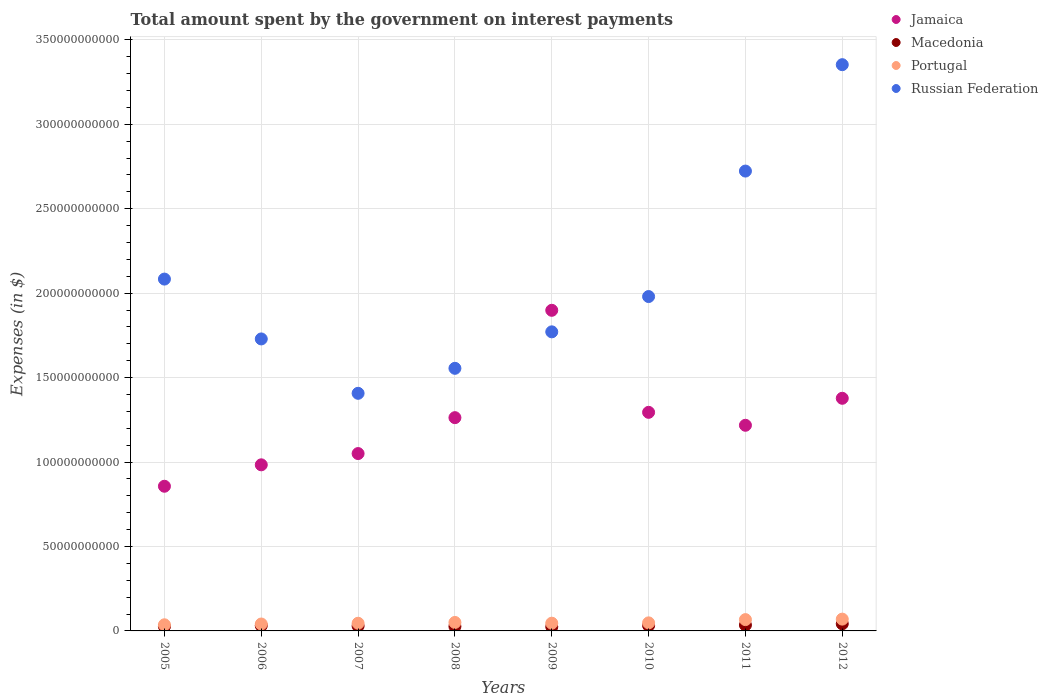How many different coloured dotlines are there?
Ensure brevity in your answer.  4. What is the amount spent on interest payments by the government in Portugal in 2006?
Offer a very short reply. 4.10e+09. Across all years, what is the maximum amount spent on interest payments by the government in Jamaica?
Keep it short and to the point. 1.90e+11. Across all years, what is the minimum amount spent on interest payments by the government in Russian Federation?
Offer a very short reply. 1.41e+11. In which year was the amount spent on interest payments by the government in Jamaica minimum?
Your response must be concise. 2005. What is the total amount spent on interest payments by the government in Russian Federation in the graph?
Your answer should be compact. 1.66e+12. What is the difference between the amount spent on interest payments by the government in Portugal in 2005 and that in 2010?
Your answer should be compact. -1.14e+09. What is the difference between the amount spent on interest payments by the government in Portugal in 2010 and the amount spent on interest payments by the government in Macedonia in 2007?
Offer a terse response. 1.85e+09. What is the average amount spent on interest payments by the government in Russian Federation per year?
Give a very brief answer. 2.08e+11. In the year 2011, what is the difference between the amount spent on interest payments by the government in Jamaica and amount spent on interest payments by the government in Macedonia?
Ensure brevity in your answer.  1.18e+11. What is the ratio of the amount spent on interest payments by the government in Portugal in 2005 to that in 2007?
Give a very brief answer. 0.8. Is the amount spent on interest payments by the government in Portugal in 2008 less than that in 2010?
Keep it short and to the point. No. What is the difference between the highest and the second highest amount spent on interest payments by the government in Jamaica?
Provide a succinct answer. 5.21e+1. What is the difference between the highest and the lowest amount spent on interest payments by the government in Jamaica?
Your answer should be compact. 1.04e+11. In how many years, is the amount spent on interest payments by the government in Portugal greater than the average amount spent on interest payments by the government in Portugal taken over all years?
Provide a short and direct response. 2. Is the sum of the amount spent on interest payments by the government in Jamaica in 2008 and 2012 greater than the maximum amount spent on interest payments by the government in Macedonia across all years?
Provide a short and direct response. Yes. Is it the case that in every year, the sum of the amount spent on interest payments by the government in Jamaica and amount spent on interest payments by the government in Portugal  is greater than the sum of amount spent on interest payments by the government in Russian Federation and amount spent on interest payments by the government in Macedonia?
Your answer should be very brief. Yes. Does the amount spent on interest payments by the government in Macedonia monotonically increase over the years?
Your response must be concise. No. Is the amount spent on interest payments by the government in Macedonia strictly greater than the amount spent on interest payments by the government in Portugal over the years?
Give a very brief answer. No. Is the amount spent on interest payments by the government in Portugal strictly less than the amount spent on interest payments by the government in Russian Federation over the years?
Ensure brevity in your answer.  Yes. How many dotlines are there?
Make the answer very short. 4. What is the difference between two consecutive major ticks on the Y-axis?
Provide a succinct answer. 5.00e+1. Are the values on the major ticks of Y-axis written in scientific E-notation?
Provide a succinct answer. No. What is the title of the graph?
Make the answer very short. Total amount spent by the government on interest payments. What is the label or title of the X-axis?
Your answer should be very brief. Years. What is the label or title of the Y-axis?
Give a very brief answer. Expenses (in $). What is the Expenses (in $) of Jamaica in 2005?
Offer a very short reply. 8.57e+1. What is the Expenses (in $) in Macedonia in 2005?
Keep it short and to the point. 2.62e+09. What is the Expenses (in $) of Portugal in 2005?
Your answer should be compact. 3.63e+09. What is the Expenses (in $) of Russian Federation in 2005?
Give a very brief answer. 2.08e+11. What is the Expenses (in $) in Jamaica in 2006?
Provide a short and direct response. 9.84e+1. What is the Expenses (in $) of Macedonia in 2006?
Keep it short and to the point. 3.14e+09. What is the Expenses (in $) of Portugal in 2006?
Give a very brief answer. 4.10e+09. What is the Expenses (in $) in Russian Federation in 2006?
Your answer should be very brief. 1.73e+11. What is the Expenses (in $) of Jamaica in 2007?
Keep it short and to the point. 1.05e+11. What is the Expenses (in $) in Macedonia in 2007?
Provide a succinct answer. 2.92e+09. What is the Expenses (in $) of Portugal in 2007?
Ensure brevity in your answer.  4.54e+09. What is the Expenses (in $) in Russian Federation in 2007?
Ensure brevity in your answer.  1.41e+11. What is the Expenses (in $) in Jamaica in 2008?
Ensure brevity in your answer.  1.26e+11. What is the Expenses (in $) of Macedonia in 2008?
Provide a succinct answer. 2.65e+09. What is the Expenses (in $) in Portugal in 2008?
Provide a short and direct response. 5.02e+09. What is the Expenses (in $) in Russian Federation in 2008?
Give a very brief answer. 1.56e+11. What is the Expenses (in $) of Jamaica in 2009?
Provide a short and direct response. 1.90e+11. What is the Expenses (in $) in Macedonia in 2009?
Ensure brevity in your answer.  2.44e+09. What is the Expenses (in $) in Portugal in 2009?
Offer a very short reply. 4.58e+09. What is the Expenses (in $) in Russian Federation in 2009?
Give a very brief answer. 1.77e+11. What is the Expenses (in $) of Jamaica in 2010?
Your response must be concise. 1.29e+11. What is the Expenses (in $) of Macedonia in 2010?
Your answer should be very brief. 3.17e+09. What is the Expenses (in $) of Portugal in 2010?
Offer a terse response. 4.77e+09. What is the Expenses (in $) in Russian Federation in 2010?
Provide a succinct answer. 1.98e+11. What is the Expenses (in $) in Jamaica in 2011?
Provide a short and direct response. 1.22e+11. What is the Expenses (in $) of Macedonia in 2011?
Your answer should be very brief. 3.47e+09. What is the Expenses (in $) in Portugal in 2011?
Ensure brevity in your answer.  6.69e+09. What is the Expenses (in $) in Russian Federation in 2011?
Your response must be concise. 2.72e+11. What is the Expenses (in $) of Jamaica in 2012?
Your response must be concise. 1.38e+11. What is the Expenses (in $) of Macedonia in 2012?
Your response must be concise. 4.22e+09. What is the Expenses (in $) in Portugal in 2012?
Your answer should be compact. 6.98e+09. What is the Expenses (in $) in Russian Federation in 2012?
Your answer should be very brief. 3.35e+11. Across all years, what is the maximum Expenses (in $) in Jamaica?
Offer a terse response. 1.90e+11. Across all years, what is the maximum Expenses (in $) of Macedonia?
Make the answer very short. 4.22e+09. Across all years, what is the maximum Expenses (in $) of Portugal?
Offer a very short reply. 6.98e+09. Across all years, what is the maximum Expenses (in $) of Russian Federation?
Ensure brevity in your answer.  3.35e+11. Across all years, what is the minimum Expenses (in $) of Jamaica?
Ensure brevity in your answer.  8.57e+1. Across all years, what is the minimum Expenses (in $) of Macedonia?
Provide a succinct answer. 2.44e+09. Across all years, what is the minimum Expenses (in $) in Portugal?
Your answer should be very brief. 3.63e+09. Across all years, what is the minimum Expenses (in $) of Russian Federation?
Give a very brief answer. 1.41e+11. What is the total Expenses (in $) of Jamaica in the graph?
Ensure brevity in your answer.  9.94e+11. What is the total Expenses (in $) of Macedonia in the graph?
Provide a succinct answer. 2.46e+1. What is the total Expenses (in $) in Portugal in the graph?
Your answer should be very brief. 4.03e+1. What is the total Expenses (in $) of Russian Federation in the graph?
Offer a terse response. 1.66e+12. What is the difference between the Expenses (in $) in Jamaica in 2005 and that in 2006?
Your response must be concise. -1.27e+1. What is the difference between the Expenses (in $) in Macedonia in 2005 and that in 2006?
Offer a very short reply. -5.20e+08. What is the difference between the Expenses (in $) of Portugal in 2005 and that in 2006?
Your answer should be compact. -4.63e+08. What is the difference between the Expenses (in $) of Russian Federation in 2005 and that in 2006?
Ensure brevity in your answer.  3.54e+1. What is the difference between the Expenses (in $) of Jamaica in 2005 and that in 2007?
Your response must be concise. -1.94e+1. What is the difference between the Expenses (in $) of Macedonia in 2005 and that in 2007?
Provide a succinct answer. -2.99e+08. What is the difference between the Expenses (in $) of Portugal in 2005 and that in 2007?
Your answer should be compact. -9.07e+08. What is the difference between the Expenses (in $) of Russian Federation in 2005 and that in 2007?
Offer a terse response. 6.76e+1. What is the difference between the Expenses (in $) of Jamaica in 2005 and that in 2008?
Your response must be concise. -4.06e+1. What is the difference between the Expenses (in $) in Macedonia in 2005 and that in 2008?
Ensure brevity in your answer.  -2.62e+07. What is the difference between the Expenses (in $) of Portugal in 2005 and that in 2008?
Give a very brief answer. -1.39e+09. What is the difference between the Expenses (in $) of Russian Federation in 2005 and that in 2008?
Make the answer very short. 5.28e+1. What is the difference between the Expenses (in $) in Jamaica in 2005 and that in 2009?
Make the answer very short. -1.04e+11. What is the difference between the Expenses (in $) in Macedonia in 2005 and that in 2009?
Your response must be concise. 1.75e+08. What is the difference between the Expenses (in $) of Portugal in 2005 and that in 2009?
Provide a short and direct response. -9.44e+08. What is the difference between the Expenses (in $) of Russian Federation in 2005 and that in 2009?
Provide a short and direct response. 3.12e+1. What is the difference between the Expenses (in $) of Jamaica in 2005 and that in 2010?
Your answer should be compact. -4.38e+1. What is the difference between the Expenses (in $) in Macedonia in 2005 and that in 2010?
Provide a succinct answer. -5.54e+08. What is the difference between the Expenses (in $) of Portugal in 2005 and that in 2010?
Make the answer very short. -1.14e+09. What is the difference between the Expenses (in $) of Russian Federation in 2005 and that in 2010?
Make the answer very short. 1.03e+1. What is the difference between the Expenses (in $) in Jamaica in 2005 and that in 2011?
Provide a succinct answer. -3.61e+1. What is the difference between the Expenses (in $) in Macedonia in 2005 and that in 2011?
Your response must be concise. -8.51e+08. What is the difference between the Expenses (in $) of Portugal in 2005 and that in 2011?
Make the answer very short. -3.06e+09. What is the difference between the Expenses (in $) in Russian Federation in 2005 and that in 2011?
Give a very brief answer. -6.40e+1. What is the difference between the Expenses (in $) of Jamaica in 2005 and that in 2012?
Make the answer very short. -5.21e+1. What is the difference between the Expenses (in $) in Macedonia in 2005 and that in 2012?
Offer a very short reply. -1.60e+09. What is the difference between the Expenses (in $) of Portugal in 2005 and that in 2012?
Your answer should be very brief. -3.35e+09. What is the difference between the Expenses (in $) in Russian Federation in 2005 and that in 2012?
Ensure brevity in your answer.  -1.27e+11. What is the difference between the Expenses (in $) in Jamaica in 2006 and that in 2007?
Your answer should be compact. -6.67e+09. What is the difference between the Expenses (in $) of Macedonia in 2006 and that in 2007?
Your answer should be very brief. 2.22e+08. What is the difference between the Expenses (in $) of Portugal in 2006 and that in 2007?
Offer a very short reply. -4.44e+08. What is the difference between the Expenses (in $) in Russian Federation in 2006 and that in 2007?
Your response must be concise. 3.22e+1. What is the difference between the Expenses (in $) of Jamaica in 2006 and that in 2008?
Your answer should be compact. -2.79e+1. What is the difference between the Expenses (in $) in Macedonia in 2006 and that in 2008?
Ensure brevity in your answer.  4.94e+08. What is the difference between the Expenses (in $) of Portugal in 2006 and that in 2008?
Offer a very short reply. -9.23e+08. What is the difference between the Expenses (in $) of Russian Federation in 2006 and that in 2008?
Give a very brief answer. 1.74e+1. What is the difference between the Expenses (in $) in Jamaica in 2006 and that in 2009?
Your answer should be compact. -9.15e+1. What is the difference between the Expenses (in $) in Macedonia in 2006 and that in 2009?
Provide a succinct answer. 6.95e+08. What is the difference between the Expenses (in $) of Portugal in 2006 and that in 2009?
Keep it short and to the point. -4.81e+08. What is the difference between the Expenses (in $) in Russian Federation in 2006 and that in 2009?
Offer a very short reply. -4.20e+09. What is the difference between the Expenses (in $) of Jamaica in 2006 and that in 2010?
Give a very brief answer. -3.11e+1. What is the difference between the Expenses (in $) of Macedonia in 2006 and that in 2010?
Keep it short and to the point. -3.39e+07. What is the difference between the Expenses (in $) in Portugal in 2006 and that in 2010?
Provide a succinct answer. -6.76e+08. What is the difference between the Expenses (in $) of Russian Federation in 2006 and that in 2010?
Make the answer very short. -2.51e+1. What is the difference between the Expenses (in $) in Jamaica in 2006 and that in 2011?
Provide a short and direct response. -2.34e+1. What is the difference between the Expenses (in $) in Macedonia in 2006 and that in 2011?
Give a very brief answer. -3.31e+08. What is the difference between the Expenses (in $) in Portugal in 2006 and that in 2011?
Ensure brevity in your answer.  -2.60e+09. What is the difference between the Expenses (in $) in Russian Federation in 2006 and that in 2011?
Your answer should be very brief. -9.94e+1. What is the difference between the Expenses (in $) of Jamaica in 2006 and that in 2012?
Ensure brevity in your answer.  -3.94e+1. What is the difference between the Expenses (in $) of Macedonia in 2006 and that in 2012?
Provide a short and direct response. -1.08e+09. What is the difference between the Expenses (in $) in Portugal in 2006 and that in 2012?
Offer a terse response. -2.89e+09. What is the difference between the Expenses (in $) of Russian Federation in 2006 and that in 2012?
Make the answer very short. -1.62e+11. What is the difference between the Expenses (in $) in Jamaica in 2007 and that in 2008?
Offer a terse response. -2.13e+1. What is the difference between the Expenses (in $) of Macedonia in 2007 and that in 2008?
Offer a terse response. 2.72e+08. What is the difference between the Expenses (in $) of Portugal in 2007 and that in 2008?
Make the answer very short. -4.79e+08. What is the difference between the Expenses (in $) of Russian Federation in 2007 and that in 2008?
Offer a very short reply. -1.48e+1. What is the difference between the Expenses (in $) of Jamaica in 2007 and that in 2009?
Offer a very short reply. -8.48e+1. What is the difference between the Expenses (in $) of Macedonia in 2007 and that in 2009?
Provide a short and direct response. 4.73e+08. What is the difference between the Expenses (in $) of Portugal in 2007 and that in 2009?
Provide a short and direct response. -3.71e+07. What is the difference between the Expenses (in $) of Russian Federation in 2007 and that in 2009?
Give a very brief answer. -3.64e+1. What is the difference between the Expenses (in $) in Jamaica in 2007 and that in 2010?
Offer a very short reply. -2.44e+1. What is the difference between the Expenses (in $) in Macedonia in 2007 and that in 2010?
Offer a terse response. -2.56e+08. What is the difference between the Expenses (in $) of Portugal in 2007 and that in 2010?
Give a very brief answer. -2.32e+08. What is the difference between the Expenses (in $) of Russian Federation in 2007 and that in 2010?
Make the answer very short. -5.73e+1. What is the difference between the Expenses (in $) of Jamaica in 2007 and that in 2011?
Ensure brevity in your answer.  -1.67e+1. What is the difference between the Expenses (in $) of Macedonia in 2007 and that in 2011?
Keep it short and to the point. -5.53e+08. What is the difference between the Expenses (in $) of Portugal in 2007 and that in 2011?
Keep it short and to the point. -2.15e+09. What is the difference between the Expenses (in $) of Russian Federation in 2007 and that in 2011?
Offer a terse response. -1.32e+11. What is the difference between the Expenses (in $) of Jamaica in 2007 and that in 2012?
Provide a succinct answer. -3.27e+1. What is the difference between the Expenses (in $) of Macedonia in 2007 and that in 2012?
Your answer should be compact. -1.30e+09. What is the difference between the Expenses (in $) in Portugal in 2007 and that in 2012?
Provide a succinct answer. -2.44e+09. What is the difference between the Expenses (in $) of Russian Federation in 2007 and that in 2012?
Your answer should be very brief. -1.95e+11. What is the difference between the Expenses (in $) of Jamaica in 2008 and that in 2009?
Ensure brevity in your answer.  -6.36e+1. What is the difference between the Expenses (in $) in Macedonia in 2008 and that in 2009?
Offer a very short reply. 2.01e+08. What is the difference between the Expenses (in $) in Portugal in 2008 and that in 2009?
Make the answer very short. 4.42e+08. What is the difference between the Expenses (in $) in Russian Federation in 2008 and that in 2009?
Provide a short and direct response. -2.16e+1. What is the difference between the Expenses (in $) of Jamaica in 2008 and that in 2010?
Your response must be concise. -3.15e+09. What is the difference between the Expenses (in $) in Macedonia in 2008 and that in 2010?
Offer a very short reply. -5.28e+08. What is the difference between the Expenses (in $) in Portugal in 2008 and that in 2010?
Your answer should be compact. 2.47e+08. What is the difference between the Expenses (in $) in Russian Federation in 2008 and that in 2010?
Offer a terse response. -4.25e+1. What is the difference between the Expenses (in $) in Jamaica in 2008 and that in 2011?
Provide a short and direct response. 4.51e+09. What is the difference between the Expenses (in $) in Macedonia in 2008 and that in 2011?
Give a very brief answer. -8.25e+08. What is the difference between the Expenses (in $) in Portugal in 2008 and that in 2011?
Provide a short and direct response. -1.68e+09. What is the difference between the Expenses (in $) in Russian Federation in 2008 and that in 2011?
Provide a short and direct response. -1.17e+11. What is the difference between the Expenses (in $) of Jamaica in 2008 and that in 2012?
Your response must be concise. -1.15e+1. What is the difference between the Expenses (in $) in Macedonia in 2008 and that in 2012?
Ensure brevity in your answer.  -1.57e+09. What is the difference between the Expenses (in $) in Portugal in 2008 and that in 2012?
Keep it short and to the point. -1.96e+09. What is the difference between the Expenses (in $) in Russian Federation in 2008 and that in 2012?
Keep it short and to the point. -1.80e+11. What is the difference between the Expenses (in $) in Jamaica in 2009 and that in 2010?
Offer a terse response. 6.04e+1. What is the difference between the Expenses (in $) in Macedonia in 2009 and that in 2010?
Offer a terse response. -7.29e+08. What is the difference between the Expenses (in $) of Portugal in 2009 and that in 2010?
Offer a very short reply. -1.95e+08. What is the difference between the Expenses (in $) in Russian Federation in 2009 and that in 2010?
Provide a short and direct response. -2.09e+1. What is the difference between the Expenses (in $) in Jamaica in 2009 and that in 2011?
Make the answer very short. 6.81e+1. What is the difference between the Expenses (in $) in Macedonia in 2009 and that in 2011?
Offer a very short reply. -1.03e+09. What is the difference between the Expenses (in $) in Portugal in 2009 and that in 2011?
Your answer should be very brief. -2.12e+09. What is the difference between the Expenses (in $) in Russian Federation in 2009 and that in 2011?
Your answer should be compact. -9.52e+1. What is the difference between the Expenses (in $) in Jamaica in 2009 and that in 2012?
Offer a very short reply. 5.21e+1. What is the difference between the Expenses (in $) of Macedonia in 2009 and that in 2012?
Give a very brief answer. -1.77e+09. What is the difference between the Expenses (in $) in Portugal in 2009 and that in 2012?
Your response must be concise. -2.41e+09. What is the difference between the Expenses (in $) in Russian Federation in 2009 and that in 2012?
Your answer should be very brief. -1.58e+11. What is the difference between the Expenses (in $) of Jamaica in 2010 and that in 2011?
Provide a short and direct response. 7.67e+09. What is the difference between the Expenses (in $) in Macedonia in 2010 and that in 2011?
Provide a short and direct response. -2.97e+08. What is the difference between the Expenses (in $) of Portugal in 2010 and that in 2011?
Your response must be concise. -1.92e+09. What is the difference between the Expenses (in $) of Russian Federation in 2010 and that in 2011?
Offer a very short reply. -7.43e+1. What is the difference between the Expenses (in $) in Jamaica in 2010 and that in 2012?
Offer a terse response. -8.32e+09. What is the difference between the Expenses (in $) in Macedonia in 2010 and that in 2012?
Make the answer very short. -1.04e+09. What is the difference between the Expenses (in $) in Portugal in 2010 and that in 2012?
Provide a short and direct response. -2.21e+09. What is the difference between the Expenses (in $) of Russian Federation in 2010 and that in 2012?
Give a very brief answer. -1.37e+11. What is the difference between the Expenses (in $) in Jamaica in 2011 and that in 2012?
Provide a short and direct response. -1.60e+1. What is the difference between the Expenses (in $) of Macedonia in 2011 and that in 2012?
Give a very brief answer. -7.45e+08. What is the difference between the Expenses (in $) of Portugal in 2011 and that in 2012?
Provide a short and direct response. -2.90e+08. What is the difference between the Expenses (in $) of Russian Federation in 2011 and that in 2012?
Give a very brief answer. -6.30e+1. What is the difference between the Expenses (in $) in Jamaica in 2005 and the Expenses (in $) in Macedonia in 2006?
Keep it short and to the point. 8.25e+1. What is the difference between the Expenses (in $) in Jamaica in 2005 and the Expenses (in $) in Portugal in 2006?
Offer a very short reply. 8.16e+1. What is the difference between the Expenses (in $) of Jamaica in 2005 and the Expenses (in $) of Russian Federation in 2006?
Your response must be concise. -8.72e+1. What is the difference between the Expenses (in $) in Macedonia in 2005 and the Expenses (in $) in Portugal in 2006?
Your response must be concise. -1.48e+09. What is the difference between the Expenses (in $) of Macedonia in 2005 and the Expenses (in $) of Russian Federation in 2006?
Your answer should be very brief. -1.70e+11. What is the difference between the Expenses (in $) in Portugal in 2005 and the Expenses (in $) in Russian Federation in 2006?
Provide a succinct answer. -1.69e+11. What is the difference between the Expenses (in $) of Jamaica in 2005 and the Expenses (in $) of Macedonia in 2007?
Your response must be concise. 8.27e+1. What is the difference between the Expenses (in $) in Jamaica in 2005 and the Expenses (in $) in Portugal in 2007?
Provide a short and direct response. 8.11e+1. What is the difference between the Expenses (in $) in Jamaica in 2005 and the Expenses (in $) in Russian Federation in 2007?
Your response must be concise. -5.50e+1. What is the difference between the Expenses (in $) in Macedonia in 2005 and the Expenses (in $) in Portugal in 2007?
Your response must be concise. -1.92e+09. What is the difference between the Expenses (in $) in Macedonia in 2005 and the Expenses (in $) in Russian Federation in 2007?
Your response must be concise. -1.38e+11. What is the difference between the Expenses (in $) in Portugal in 2005 and the Expenses (in $) in Russian Federation in 2007?
Provide a succinct answer. -1.37e+11. What is the difference between the Expenses (in $) in Jamaica in 2005 and the Expenses (in $) in Macedonia in 2008?
Offer a very short reply. 8.30e+1. What is the difference between the Expenses (in $) of Jamaica in 2005 and the Expenses (in $) of Portugal in 2008?
Provide a succinct answer. 8.06e+1. What is the difference between the Expenses (in $) of Jamaica in 2005 and the Expenses (in $) of Russian Federation in 2008?
Your response must be concise. -6.98e+1. What is the difference between the Expenses (in $) in Macedonia in 2005 and the Expenses (in $) in Portugal in 2008?
Your response must be concise. -2.40e+09. What is the difference between the Expenses (in $) of Macedonia in 2005 and the Expenses (in $) of Russian Federation in 2008?
Keep it short and to the point. -1.53e+11. What is the difference between the Expenses (in $) of Portugal in 2005 and the Expenses (in $) of Russian Federation in 2008?
Make the answer very short. -1.52e+11. What is the difference between the Expenses (in $) in Jamaica in 2005 and the Expenses (in $) in Macedonia in 2009?
Provide a succinct answer. 8.32e+1. What is the difference between the Expenses (in $) in Jamaica in 2005 and the Expenses (in $) in Portugal in 2009?
Keep it short and to the point. 8.11e+1. What is the difference between the Expenses (in $) in Jamaica in 2005 and the Expenses (in $) in Russian Federation in 2009?
Make the answer very short. -9.14e+1. What is the difference between the Expenses (in $) of Macedonia in 2005 and the Expenses (in $) of Portugal in 2009?
Ensure brevity in your answer.  -1.96e+09. What is the difference between the Expenses (in $) in Macedonia in 2005 and the Expenses (in $) in Russian Federation in 2009?
Your answer should be compact. -1.74e+11. What is the difference between the Expenses (in $) of Portugal in 2005 and the Expenses (in $) of Russian Federation in 2009?
Your answer should be compact. -1.73e+11. What is the difference between the Expenses (in $) in Jamaica in 2005 and the Expenses (in $) in Macedonia in 2010?
Keep it short and to the point. 8.25e+1. What is the difference between the Expenses (in $) in Jamaica in 2005 and the Expenses (in $) in Portugal in 2010?
Your answer should be compact. 8.09e+1. What is the difference between the Expenses (in $) of Jamaica in 2005 and the Expenses (in $) of Russian Federation in 2010?
Offer a terse response. -1.12e+11. What is the difference between the Expenses (in $) in Macedonia in 2005 and the Expenses (in $) in Portugal in 2010?
Offer a very short reply. -2.15e+09. What is the difference between the Expenses (in $) of Macedonia in 2005 and the Expenses (in $) of Russian Federation in 2010?
Make the answer very short. -1.95e+11. What is the difference between the Expenses (in $) in Portugal in 2005 and the Expenses (in $) in Russian Federation in 2010?
Keep it short and to the point. -1.94e+11. What is the difference between the Expenses (in $) of Jamaica in 2005 and the Expenses (in $) of Macedonia in 2011?
Provide a short and direct response. 8.22e+1. What is the difference between the Expenses (in $) in Jamaica in 2005 and the Expenses (in $) in Portugal in 2011?
Your response must be concise. 7.90e+1. What is the difference between the Expenses (in $) of Jamaica in 2005 and the Expenses (in $) of Russian Federation in 2011?
Ensure brevity in your answer.  -1.87e+11. What is the difference between the Expenses (in $) in Macedonia in 2005 and the Expenses (in $) in Portugal in 2011?
Give a very brief answer. -4.07e+09. What is the difference between the Expenses (in $) in Macedonia in 2005 and the Expenses (in $) in Russian Federation in 2011?
Make the answer very short. -2.70e+11. What is the difference between the Expenses (in $) in Portugal in 2005 and the Expenses (in $) in Russian Federation in 2011?
Ensure brevity in your answer.  -2.69e+11. What is the difference between the Expenses (in $) of Jamaica in 2005 and the Expenses (in $) of Macedonia in 2012?
Ensure brevity in your answer.  8.15e+1. What is the difference between the Expenses (in $) of Jamaica in 2005 and the Expenses (in $) of Portugal in 2012?
Give a very brief answer. 7.87e+1. What is the difference between the Expenses (in $) of Jamaica in 2005 and the Expenses (in $) of Russian Federation in 2012?
Give a very brief answer. -2.50e+11. What is the difference between the Expenses (in $) of Macedonia in 2005 and the Expenses (in $) of Portugal in 2012?
Your answer should be compact. -4.36e+09. What is the difference between the Expenses (in $) of Macedonia in 2005 and the Expenses (in $) of Russian Federation in 2012?
Your response must be concise. -3.33e+11. What is the difference between the Expenses (in $) of Portugal in 2005 and the Expenses (in $) of Russian Federation in 2012?
Give a very brief answer. -3.32e+11. What is the difference between the Expenses (in $) in Jamaica in 2006 and the Expenses (in $) in Macedonia in 2007?
Keep it short and to the point. 9.54e+1. What is the difference between the Expenses (in $) in Jamaica in 2006 and the Expenses (in $) in Portugal in 2007?
Offer a terse response. 9.38e+1. What is the difference between the Expenses (in $) of Jamaica in 2006 and the Expenses (in $) of Russian Federation in 2007?
Give a very brief answer. -4.23e+1. What is the difference between the Expenses (in $) of Macedonia in 2006 and the Expenses (in $) of Portugal in 2007?
Your answer should be very brief. -1.40e+09. What is the difference between the Expenses (in $) in Macedonia in 2006 and the Expenses (in $) in Russian Federation in 2007?
Your answer should be very brief. -1.38e+11. What is the difference between the Expenses (in $) in Portugal in 2006 and the Expenses (in $) in Russian Federation in 2007?
Offer a terse response. -1.37e+11. What is the difference between the Expenses (in $) in Jamaica in 2006 and the Expenses (in $) in Macedonia in 2008?
Ensure brevity in your answer.  9.57e+1. What is the difference between the Expenses (in $) of Jamaica in 2006 and the Expenses (in $) of Portugal in 2008?
Give a very brief answer. 9.33e+1. What is the difference between the Expenses (in $) in Jamaica in 2006 and the Expenses (in $) in Russian Federation in 2008?
Give a very brief answer. -5.71e+1. What is the difference between the Expenses (in $) of Macedonia in 2006 and the Expenses (in $) of Portugal in 2008?
Provide a succinct answer. -1.88e+09. What is the difference between the Expenses (in $) of Macedonia in 2006 and the Expenses (in $) of Russian Federation in 2008?
Provide a succinct answer. -1.52e+11. What is the difference between the Expenses (in $) in Portugal in 2006 and the Expenses (in $) in Russian Federation in 2008?
Give a very brief answer. -1.51e+11. What is the difference between the Expenses (in $) in Jamaica in 2006 and the Expenses (in $) in Macedonia in 2009?
Make the answer very short. 9.59e+1. What is the difference between the Expenses (in $) of Jamaica in 2006 and the Expenses (in $) of Portugal in 2009?
Ensure brevity in your answer.  9.38e+1. What is the difference between the Expenses (in $) in Jamaica in 2006 and the Expenses (in $) in Russian Federation in 2009?
Offer a terse response. -7.87e+1. What is the difference between the Expenses (in $) in Macedonia in 2006 and the Expenses (in $) in Portugal in 2009?
Keep it short and to the point. -1.44e+09. What is the difference between the Expenses (in $) of Macedonia in 2006 and the Expenses (in $) of Russian Federation in 2009?
Your answer should be compact. -1.74e+11. What is the difference between the Expenses (in $) of Portugal in 2006 and the Expenses (in $) of Russian Federation in 2009?
Provide a succinct answer. -1.73e+11. What is the difference between the Expenses (in $) in Jamaica in 2006 and the Expenses (in $) in Macedonia in 2010?
Provide a short and direct response. 9.52e+1. What is the difference between the Expenses (in $) in Jamaica in 2006 and the Expenses (in $) in Portugal in 2010?
Offer a terse response. 9.36e+1. What is the difference between the Expenses (in $) of Jamaica in 2006 and the Expenses (in $) of Russian Federation in 2010?
Keep it short and to the point. -9.96e+1. What is the difference between the Expenses (in $) of Macedonia in 2006 and the Expenses (in $) of Portugal in 2010?
Ensure brevity in your answer.  -1.63e+09. What is the difference between the Expenses (in $) in Macedonia in 2006 and the Expenses (in $) in Russian Federation in 2010?
Offer a terse response. -1.95e+11. What is the difference between the Expenses (in $) of Portugal in 2006 and the Expenses (in $) of Russian Federation in 2010?
Give a very brief answer. -1.94e+11. What is the difference between the Expenses (in $) in Jamaica in 2006 and the Expenses (in $) in Macedonia in 2011?
Provide a succinct answer. 9.49e+1. What is the difference between the Expenses (in $) in Jamaica in 2006 and the Expenses (in $) in Portugal in 2011?
Offer a very short reply. 9.17e+1. What is the difference between the Expenses (in $) in Jamaica in 2006 and the Expenses (in $) in Russian Federation in 2011?
Give a very brief answer. -1.74e+11. What is the difference between the Expenses (in $) of Macedonia in 2006 and the Expenses (in $) of Portugal in 2011?
Ensure brevity in your answer.  -3.55e+09. What is the difference between the Expenses (in $) of Macedonia in 2006 and the Expenses (in $) of Russian Federation in 2011?
Offer a very short reply. -2.69e+11. What is the difference between the Expenses (in $) of Portugal in 2006 and the Expenses (in $) of Russian Federation in 2011?
Give a very brief answer. -2.68e+11. What is the difference between the Expenses (in $) in Jamaica in 2006 and the Expenses (in $) in Macedonia in 2012?
Provide a short and direct response. 9.41e+1. What is the difference between the Expenses (in $) in Jamaica in 2006 and the Expenses (in $) in Portugal in 2012?
Give a very brief answer. 9.14e+1. What is the difference between the Expenses (in $) of Jamaica in 2006 and the Expenses (in $) of Russian Federation in 2012?
Offer a terse response. -2.37e+11. What is the difference between the Expenses (in $) in Macedonia in 2006 and the Expenses (in $) in Portugal in 2012?
Provide a short and direct response. -3.84e+09. What is the difference between the Expenses (in $) in Macedonia in 2006 and the Expenses (in $) in Russian Federation in 2012?
Your response must be concise. -3.32e+11. What is the difference between the Expenses (in $) of Portugal in 2006 and the Expenses (in $) of Russian Federation in 2012?
Your answer should be compact. -3.31e+11. What is the difference between the Expenses (in $) of Jamaica in 2007 and the Expenses (in $) of Macedonia in 2008?
Provide a short and direct response. 1.02e+11. What is the difference between the Expenses (in $) in Jamaica in 2007 and the Expenses (in $) in Portugal in 2008?
Keep it short and to the point. 1.00e+11. What is the difference between the Expenses (in $) of Jamaica in 2007 and the Expenses (in $) of Russian Federation in 2008?
Provide a short and direct response. -5.05e+1. What is the difference between the Expenses (in $) in Macedonia in 2007 and the Expenses (in $) in Portugal in 2008?
Make the answer very short. -2.10e+09. What is the difference between the Expenses (in $) in Macedonia in 2007 and the Expenses (in $) in Russian Federation in 2008?
Offer a terse response. -1.53e+11. What is the difference between the Expenses (in $) of Portugal in 2007 and the Expenses (in $) of Russian Federation in 2008?
Ensure brevity in your answer.  -1.51e+11. What is the difference between the Expenses (in $) in Jamaica in 2007 and the Expenses (in $) in Macedonia in 2009?
Provide a short and direct response. 1.03e+11. What is the difference between the Expenses (in $) in Jamaica in 2007 and the Expenses (in $) in Portugal in 2009?
Offer a very short reply. 1.00e+11. What is the difference between the Expenses (in $) in Jamaica in 2007 and the Expenses (in $) in Russian Federation in 2009?
Your response must be concise. -7.21e+1. What is the difference between the Expenses (in $) of Macedonia in 2007 and the Expenses (in $) of Portugal in 2009?
Give a very brief answer. -1.66e+09. What is the difference between the Expenses (in $) of Macedonia in 2007 and the Expenses (in $) of Russian Federation in 2009?
Make the answer very short. -1.74e+11. What is the difference between the Expenses (in $) of Portugal in 2007 and the Expenses (in $) of Russian Federation in 2009?
Give a very brief answer. -1.73e+11. What is the difference between the Expenses (in $) of Jamaica in 2007 and the Expenses (in $) of Macedonia in 2010?
Make the answer very short. 1.02e+11. What is the difference between the Expenses (in $) in Jamaica in 2007 and the Expenses (in $) in Portugal in 2010?
Offer a terse response. 1.00e+11. What is the difference between the Expenses (in $) in Jamaica in 2007 and the Expenses (in $) in Russian Federation in 2010?
Your answer should be very brief. -9.30e+1. What is the difference between the Expenses (in $) of Macedonia in 2007 and the Expenses (in $) of Portugal in 2010?
Your answer should be compact. -1.85e+09. What is the difference between the Expenses (in $) in Macedonia in 2007 and the Expenses (in $) in Russian Federation in 2010?
Offer a very short reply. -1.95e+11. What is the difference between the Expenses (in $) of Portugal in 2007 and the Expenses (in $) of Russian Federation in 2010?
Your response must be concise. -1.93e+11. What is the difference between the Expenses (in $) of Jamaica in 2007 and the Expenses (in $) of Macedonia in 2011?
Your response must be concise. 1.02e+11. What is the difference between the Expenses (in $) of Jamaica in 2007 and the Expenses (in $) of Portugal in 2011?
Your response must be concise. 9.83e+1. What is the difference between the Expenses (in $) of Jamaica in 2007 and the Expenses (in $) of Russian Federation in 2011?
Make the answer very short. -1.67e+11. What is the difference between the Expenses (in $) of Macedonia in 2007 and the Expenses (in $) of Portugal in 2011?
Offer a very short reply. -3.78e+09. What is the difference between the Expenses (in $) in Macedonia in 2007 and the Expenses (in $) in Russian Federation in 2011?
Your answer should be very brief. -2.69e+11. What is the difference between the Expenses (in $) of Portugal in 2007 and the Expenses (in $) of Russian Federation in 2011?
Your answer should be compact. -2.68e+11. What is the difference between the Expenses (in $) in Jamaica in 2007 and the Expenses (in $) in Macedonia in 2012?
Ensure brevity in your answer.  1.01e+11. What is the difference between the Expenses (in $) of Jamaica in 2007 and the Expenses (in $) of Portugal in 2012?
Provide a short and direct response. 9.80e+1. What is the difference between the Expenses (in $) in Jamaica in 2007 and the Expenses (in $) in Russian Federation in 2012?
Make the answer very short. -2.30e+11. What is the difference between the Expenses (in $) of Macedonia in 2007 and the Expenses (in $) of Portugal in 2012?
Offer a very short reply. -4.07e+09. What is the difference between the Expenses (in $) of Macedonia in 2007 and the Expenses (in $) of Russian Federation in 2012?
Make the answer very short. -3.32e+11. What is the difference between the Expenses (in $) of Portugal in 2007 and the Expenses (in $) of Russian Federation in 2012?
Your response must be concise. -3.31e+11. What is the difference between the Expenses (in $) of Jamaica in 2008 and the Expenses (in $) of Macedonia in 2009?
Your answer should be very brief. 1.24e+11. What is the difference between the Expenses (in $) in Jamaica in 2008 and the Expenses (in $) in Portugal in 2009?
Give a very brief answer. 1.22e+11. What is the difference between the Expenses (in $) in Jamaica in 2008 and the Expenses (in $) in Russian Federation in 2009?
Your response must be concise. -5.08e+1. What is the difference between the Expenses (in $) of Macedonia in 2008 and the Expenses (in $) of Portugal in 2009?
Provide a succinct answer. -1.93e+09. What is the difference between the Expenses (in $) in Macedonia in 2008 and the Expenses (in $) in Russian Federation in 2009?
Offer a very short reply. -1.74e+11. What is the difference between the Expenses (in $) of Portugal in 2008 and the Expenses (in $) of Russian Federation in 2009?
Provide a short and direct response. -1.72e+11. What is the difference between the Expenses (in $) in Jamaica in 2008 and the Expenses (in $) in Macedonia in 2010?
Give a very brief answer. 1.23e+11. What is the difference between the Expenses (in $) of Jamaica in 2008 and the Expenses (in $) of Portugal in 2010?
Your answer should be compact. 1.22e+11. What is the difference between the Expenses (in $) of Jamaica in 2008 and the Expenses (in $) of Russian Federation in 2010?
Provide a short and direct response. -7.17e+1. What is the difference between the Expenses (in $) of Macedonia in 2008 and the Expenses (in $) of Portugal in 2010?
Provide a short and direct response. -2.13e+09. What is the difference between the Expenses (in $) of Macedonia in 2008 and the Expenses (in $) of Russian Federation in 2010?
Offer a terse response. -1.95e+11. What is the difference between the Expenses (in $) in Portugal in 2008 and the Expenses (in $) in Russian Federation in 2010?
Offer a terse response. -1.93e+11. What is the difference between the Expenses (in $) of Jamaica in 2008 and the Expenses (in $) of Macedonia in 2011?
Provide a succinct answer. 1.23e+11. What is the difference between the Expenses (in $) of Jamaica in 2008 and the Expenses (in $) of Portugal in 2011?
Give a very brief answer. 1.20e+11. What is the difference between the Expenses (in $) of Jamaica in 2008 and the Expenses (in $) of Russian Federation in 2011?
Your response must be concise. -1.46e+11. What is the difference between the Expenses (in $) in Macedonia in 2008 and the Expenses (in $) in Portugal in 2011?
Your answer should be compact. -4.05e+09. What is the difference between the Expenses (in $) of Macedonia in 2008 and the Expenses (in $) of Russian Federation in 2011?
Your response must be concise. -2.70e+11. What is the difference between the Expenses (in $) of Portugal in 2008 and the Expenses (in $) of Russian Federation in 2011?
Your answer should be compact. -2.67e+11. What is the difference between the Expenses (in $) in Jamaica in 2008 and the Expenses (in $) in Macedonia in 2012?
Make the answer very short. 1.22e+11. What is the difference between the Expenses (in $) of Jamaica in 2008 and the Expenses (in $) of Portugal in 2012?
Your answer should be compact. 1.19e+11. What is the difference between the Expenses (in $) of Jamaica in 2008 and the Expenses (in $) of Russian Federation in 2012?
Make the answer very short. -2.09e+11. What is the difference between the Expenses (in $) of Macedonia in 2008 and the Expenses (in $) of Portugal in 2012?
Provide a short and direct response. -4.34e+09. What is the difference between the Expenses (in $) of Macedonia in 2008 and the Expenses (in $) of Russian Federation in 2012?
Make the answer very short. -3.33e+11. What is the difference between the Expenses (in $) of Portugal in 2008 and the Expenses (in $) of Russian Federation in 2012?
Keep it short and to the point. -3.30e+11. What is the difference between the Expenses (in $) in Jamaica in 2009 and the Expenses (in $) in Macedonia in 2010?
Provide a short and direct response. 1.87e+11. What is the difference between the Expenses (in $) of Jamaica in 2009 and the Expenses (in $) of Portugal in 2010?
Give a very brief answer. 1.85e+11. What is the difference between the Expenses (in $) in Jamaica in 2009 and the Expenses (in $) in Russian Federation in 2010?
Your answer should be very brief. -8.15e+09. What is the difference between the Expenses (in $) of Macedonia in 2009 and the Expenses (in $) of Portugal in 2010?
Make the answer very short. -2.33e+09. What is the difference between the Expenses (in $) of Macedonia in 2009 and the Expenses (in $) of Russian Federation in 2010?
Your answer should be very brief. -1.96e+11. What is the difference between the Expenses (in $) of Portugal in 2009 and the Expenses (in $) of Russian Federation in 2010?
Provide a short and direct response. -1.93e+11. What is the difference between the Expenses (in $) in Jamaica in 2009 and the Expenses (in $) in Macedonia in 2011?
Ensure brevity in your answer.  1.86e+11. What is the difference between the Expenses (in $) of Jamaica in 2009 and the Expenses (in $) of Portugal in 2011?
Offer a terse response. 1.83e+11. What is the difference between the Expenses (in $) of Jamaica in 2009 and the Expenses (in $) of Russian Federation in 2011?
Make the answer very short. -8.24e+1. What is the difference between the Expenses (in $) of Macedonia in 2009 and the Expenses (in $) of Portugal in 2011?
Your response must be concise. -4.25e+09. What is the difference between the Expenses (in $) in Macedonia in 2009 and the Expenses (in $) in Russian Federation in 2011?
Provide a succinct answer. -2.70e+11. What is the difference between the Expenses (in $) of Portugal in 2009 and the Expenses (in $) of Russian Federation in 2011?
Give a very brief answer. -2.68e+11. What is the difference between the Expenses (in $) of Jamaica in 2009 and the Expenses (in $) of Macedonia in 2012?
Provide a succinct answer. 1.86e+11. What is the difference between the Expenses (in $) in Jamaica in 2009 and the Expenses (in $) in Portugal in 2012?
Your answer should be compact. 1.83e+11. What is the difference between the Expenses (in $) in Jamaica in 2009 and the Expenses (in $) in Russian Federation in 2012?
Ensure brevity in your answer.  -1.45e+11. What is the difference between the Expenses (in $) of Macedonia in 2009 and the Expenses (in $) of Portugal in 2012?
Make the answer very short. -4.54e+09. What is the difference between the Expenses (in $) in Macedonia in 2009 and the Expenses (in $) in Russian Federation in 2012?
Provide a short and direct response. -3.33e+11. What is the difference between the Expenses (in $) of Portugal in 2009 and the Expenses (in $) of Russian Federation in 2012?
Offer a terse response. -3.31e+11. What is the difference between the Expenses (in $) in Jamaica in 2010 and the Expenses (in $) in Macedonia in 2011?
Your answer should be very brief. 1.26e+11. What is the difference between the Expenses (in $) of Jamaica in 2010 and the Expenses (in $) of Portugal in 2011?
Offer a very short reply. 1.23e+11. What is the difference between the Expenses (in $) of Jamaica in 2010 and the Expenses (in $) of Russian Federation in 2011?
Keep it short and to the point. -1.43e+11. What is the difference between the Expenses (in $) of Macedonia in 2010 and the Expenses (in $) of Portugal in 2011?
Offer a very short reply. -3.52e+09. What is the difference between the Expenses (in $) of Macedonia in 2010 and the Expenses (in $) of Russian Federation in 2011?
Keep it short and to the point. -2.69e+11. What is the difference between the Expenses (in $) in Portugal in 2010 and the Expenses (in $) in Russian Federation in 2011?
Your response must be concise. -2.68e+11. What is the difference between the Expenses (in $) in Jamaica in 2010 and the Expenses (in $) in Macedonia in 2012?
Provide a succinct answer. 1.25e+11. What is the difference between the Expenses (in $) in Jamaica in 2010 and the Expenses (in $) in Portugal in 2012?
Give a very brief answer. 1.22e+11. What is the difference between the Expenses (in $) in Jamaica in 2010 and the Expenses (in $) in Russian Federation in 2012?
Offer a terse response. -2.06e+11. What is the difference between the Expenses (in $) of Macedonia in 2010 and the Expenses (in $) of Portugal in 2012?
Your answer should be compact. -3.81e+09. What is the difference between the Expenses (in $) of Macedonia in 2010 and the Expenses (in $) of Russian Federation in 2012?
Your answer should be very brief. -3.32e+11. What is the difference between the Expenses (in $) in Portugal in 2010 and the Expenses (in $) in Russian Federation in 2012?
Offer a very short reply. -3.31e+11. What is the difference between the Expenses (in $) of Jamaica in 2011 and the Expenses (in $) of Macedonia in 2012?
Keep it short and to the point. 1.18e+11. What is the difference between the Expenses (in $) in Jamaica in 2011 and the Expenses (in $) in Portugal in 2012?
Offer a very short reply. 1.15e+11. What is the difference between the Expenses (in $) of Jamaica in 2011 and the Expenses (in $) of Russian Federation in 2012?
Offer a very short reply. -2.14e+11. What is the difference between the Expenses (in $) in Macedonia in 2011 and the Expenses (in $) in Portugal in 2012?
Keep it short and to the point. -3.51e+09. What is the difference between the Expenses (in $) of Macedonia in 2011 and the Expenses (in $) of Russian Federation in 2012?
Keep it short and to the point. -3.32e+11. What is the difference between the Expenses (in $) in Portugal in 2011 and the Expenses (in $) in Russian Federation in 2012?
Ensure brevity in your answer.  -3.29e+11. What is the average Expenses (in $) of Jamaica per year?
Provide a succinct answer. 1.24e+11. What is the average Expenses (in $) in Macedonia per year?
Your answer should be very brief. 3.08e+09. What is the average Expenses (in $) of Portugal per year?
Offer a terse response. 5.04e+09. What is the average Expenses (in $) of Russian Federation per year?
Ensure brevity in your answer.  2.08e+11. In the year 2005, what is the difference between the Expenses (in $) of Jamaica and Expenses (in $) of Macedonia?
Give a very brief answer. 8.30e+1. In the year 2005, what is the difference between the Expenses (in $) in Jamaica and Expenses (in $) in Portugal?
Your answer should be very brief. 8.20e+1. In the year 2005, what is the difference between the Expenses (in $) in Jamaica and Expenses (in $) in Russian Federation?
Offer a terse response. -1.23e+11. In the year 2005, what is the difference between the Expenses (in $) in Macedonia and Expenses (in $) in Portugal?
Keep it short and to the point. -1.01e+09. In the year 2005, what is the difference between the Expenses (in $) of Macedonia and Expenses (in $) of Russian Federation?
Keep it short and to the point. -2.06e+11. In the year 2005, what is the difference between the Expenses (in $) in Portugal and Expenses (in $) in Russian Federation?
Ensure brevity in your answer.  -2.05e+11. In the year 2006, what is the difference between the Expenses (in $) of Jamaica and Expenses (in $) of Macedonia?
Offer a terse response. 9.52e+1. In the year 2006, what is the difference between the Expenses (in $) in Jamaica and Expenses (in $) in Portugal?
Your response must be concise. 9.43e+1. In the year 2006, what is the difference between the Expenses (in $) in Jamaica and Expenses (in $) in Russian Federation?
Keep it short and to the point. -7.45e+1. In the year 2006, what is the difference between the Expenses (in $) in Macedonia and Expenses (in $) in Portugal?
Your answer should be very brief. -9.56e+08. In the year 2006, what is the difference between the Expenses (in $) of Macedonia and Expenses (in $) of Russian Federation?
Your answer should be compact. -1.70e+11. In the year 2006, what is the difference between the Expenses (in $) of Portugal and Expenses (in $) of Russian Federation?
Offer a very short reply. -1.69e+11. In the year 2007, what is the difference between the Expenses (in $) in Jamaica and Expenses (in $) in Macedonia?
Give a very brief answer. 1.02e+11. In the year 2007, what is the difference between the Expenses (in $) in Jamaica and Expenses (in $) in Portugal?
Your answer should be very brief. 1.00e+11. In the year 2007, what is the difference between the Expenses (in $) in Jamaica and Expenses (in $) in Russian Federation?
Offer a very short reply. -3.57e+1. In the year 2007, what is the difference between the Expenses (in $) in Macedonia and Expenses (in $) in Portugal?
Provide a short and direct response. -1.62e+09. In the year 2007, what is the difference between the Expenses (in $) of Macedonia and Expenses (in $) of Russian Federation?
Make the answer very short. -1.38e+11. In the year 2007, what is the difference between the Expenses (in $) of Portugal and Expenses (in $) of Russian Federation?
Your response must be concise. -1.36e+11. In the year 2008, what is the difference between the Expenses (in $) of Jamaica and Expenses (in $) of Macedonia?
Make the answer very short. 1.24e+11. In the year 2008, what is the difference between the Expenses (in $) in Jamaica and Expenses (in $) in Portugal?
Your answer should be very brief. 1.21e+11. In the year 2008, what is the difference between the Expenses (in $) in Jamaica and Expenses (in $) in Russian Federation?
Give a very brief answer. -2.92e+1. In the year 2008, what is the difference between the Expenses (in $) of Macedonia and Expenses (in $) of Portugal?
Your answer should be very brief. -2.37e+09. In the year 2008, what is the difference between the Expenses (in $) of Macedonia and Expenses (in $) of Russian Federation?
Give a very brief answer. -1.53e+11. In the year 2008, what is the difference between the Expenses (in $) in Portugal and Expenses (in $) in Russian Federation?
Give a very brief answer. -1.50e+11. In the year 2009, what is the difference between the Expenses (in $) of Jamaica and Expenses (in $) of Macedonia?
Offer a very short reply. 1.87e+11. In the year 2009, what is the difference between the Expenses (in $) in Jamaica and Expenses (in $) in Portugal?
Your answer should be very brief. 1.85e+11. In the year 2009, what is the difference between the Expenses (in $) of Jamaica and Expenses (in $) of Russian Federation?
Offer a very short reply. 1.28e+1. In the year 2009, what is the difference between the Expenses (in $) in Macedonia and Expenses (in $) in Portugal?
Provide a short and direct response. -2.13e+09. In the year 2009, what is the difference between the Expenses (in $) in Macedonia and Expenses (in $) in Russian Federation?
Your answer should be very brief. -1.75e+11. In the year 2009, what is the difference between the Expenses (in $) of Portugal and Expenses (in $) of Russian Federation?
Offer a very short reply. -1.73e+11. In the year 2010, what is the difference between the Expenses (in $) in Jamaica and Expenses (in $) in Macedonia?
Your answer should be compact. 1.26e+11. In the year 2010, what is the difference between the Expenses (in $) in Jamaica and Expenses (in $) in Portugal?
Make the answer very short. 1.25e+11. In the year 2010, what is the difference between the Expenses (in $) of Jamaica and Expenses (in $) of Russian Federation?
Your answer should be compact. -6.86e+1. In the year 2010, what is the difference between the Expenses (in $) in Macedonia and Expenses (in $) in Portugal?
Give a very brief answer. -1.60e+09. In the year 2010, what is the difference between the Expenses (in $) of Macedonia and Expenses (in $) of Russian Federation?
Ensure brevity in your answer.  -1.95e+11. In the year 2010, what is the difference between the Expenses (in $) in Portugal and Expenses (in $) in Russian Federation?
Your answer should be compact. -1.93e+11. In the year 2011, what is the difference between the Expenses (in $) of Jamaica and Expenses (in $) of Macedonia?
Your answer should be very brief. 1.18e+11. In the year 2011, what is the difference between the Expenses (in $) in Jamaica and Expenses (in $) in Portugal?
Make the answer very short. 1.15e+11. In the year 2011, what is the difference between the Expenses (in $) in Jamaica and Expenses (in $) in Russian Federation?
Ensure brevity in your answer.  -1.51e+11. In the year 2011, what is the difference between the Expenses (in $) of Macedonia and Expenses (in $) of Portugal?
Your answer should be very brief. -3.22e+09. In the year 2011, what is the difference between the Expenses (in $) in Macedonia and Expenses (in $) in Russian Federation?
Your response must be concise. -2.69e+11. In the year 2011, what is the difference between the Expenses (in $) in Portugal and Expenses (in $) in Russian Federation?
Keep it short and to the point. -2.66e+11. In the year 2012, what is the difference between the Expenses (in $) in Jamaica and Expenses (in $) in Macedonia?
Keep it short and to the point. 1.34e+11. In the year 2012, what is the difference between the Expenses (in $) of Jamaica and Expenses (in $) of Portugal?
Offer a terse response. 1.31e+11. In the year 2012, what is the difference between the Expenses (in $) in Jamaica and Expenses (in $) in Russian Federation?
Your answer should be compact. -1.98e+11. In the year 2012, what is the difference between the Expenses (in $) of Macedonia and Expenses (in $) of Portugal?
Your response must be concise. -2.77e+09. In the year 2012, what is the difference between the Expenses (in $) in Macedonia and Expenses (in $) in Russian Federation?
Keep it short and to the point. -3.31e+11. In the year 2012, what is the difference between the Expenses (in $) of Portugal and Expenses (in $) of Russian Federation?
Your response must be concise. -3.28e+11. What is the ratio of the Expenses (in $) in Jamaica in 2005 to that in 2006?
Offer a very short reply. 0.87. What is the ratio of the Expenses (in $) in Macedonia in 2005 to that in 2006?
Keep it short and to the point. 0.83. What is the ratio of the Expenses (in $) in Portugal in 2005 to that in 2006?
Your answer should be very brief. 0.89. What is the ratio of the Expenses (in $) in Russian Federation in 2005 to that in 2006?
Your response must be concise. 1.21. What is the ratio of the Expenses (in $) in Jamaica in 2005 to that in 2007?
Your answer should be very brief. 0.82. What is the ratio of the Expenses (in $) of Macedonia in 2005 to that in 2007?
Offer a very short reply. 0.9. What is the ratio of the Expenses (in $) of Portugal in 2005 to that in 2007?
Your response must be concise. 0.8. What is the ratio of the Expenses (in $) of Russian Federation in 2005 to that in 2007?
Ensure brevity in your answer.  1.48. What is the ratio of the Expenses (in $) of Jamaica in 2005 to that in 2008?
Give a very brief answer. 0.68. What is the ratio of the Expenses (in $) in Portugal in 2005 to that in 2008?
Provide a succinct answer. 0.72. What is the ratio of the Expenses (in $) in Russian Federation in 2005 to that in 2008?
Ensure brevity in your answer.  1.34. What is the ratio of the Expenses (in $) in Jamaica in 2005 to that in 2009?
Your answer should be very brief. 0.45. What is the ratio of the Expenses (in $) in Macedonia in 2005 to that in 2009?
Your response must be concise. 1.07. What is the ratio of the Expenses (in $) of Portugal in 2005 to that in 2009?
Ensure brevity in your answer.  0.79. What is the ratio of the Expenses (in $) of Russian Federation in 2005 to that in 2009?
Offer a very short reply. 1.18. What is the ratio of the Expenses (in $) of Jamaica in 2005 to that in 2010?
Ensure brevity in your answer.  0.66. What is the ratio of the Expenses (in $) in Macedonia in 2005 to that in 2010?
Give a very brief answer. 0.83. What is the ratio of the Expenses (in $) in Portugal in 2005 to that in 2010?
Offer a terse response. 0.76. What is the ratio of the Expenses (in $) of Russian Federation in 2005 to that in 2010?
Provide a short and direct response. 1.05. What is the ratio of the Expenses (in $) in Jamaica in 2005 to that in 2011?
Your answer should be compact. 0.7. What is the ratio of the Expenses (in $) in Macedonia in 2005 to that in 2011?
Give a very brief answer. 0.75. What is the ratio of the Expenses (in $) of Portugal in 2005 to that in 2011?
Your answer should be very brief. 0.54. What is the ratio of the Expenses (in $) in Russian Federation in 2005 to that in 2011?
Give a very brief answer. 0.77. What is the ratio of the Expenses (in $) of Jamaica in 2005 to that in 2012?
Make the answer very short. 0.62. What is the ratio of the Expenses (in $) in Macedonia in 2005 to that in 2012?
Provide a short and direct response. 0.62. What is the ratio of the Expenses (in $) in Portugal in 2005 to that in 2012?
Your response must be concise. 0.52. What is the ratio of the Expenses (in $) of Russian Federation in 2005 to that in 2012?
Offer a very short reply. 0.62. What is the ratio of the Expenses (in $) in Jamaica in 2006 to that in 2007?
Make the answer very short. 0.94. What is the ratio of the Expenses (in $) in Macedonia in 2006 to that in 2007?
Provide a succinct answer. 1.08. What is the ratio of the Expenses (in $) in Portugal in 2006 to that in 2007?
Provide a short and direct response. 0.9. What is the ratio of the Expenses (in $) in Russian Federation in 2006 to that in 2007?
Ensure brevity in your answer.  1.23. What is the ratio of the Expenses (in $) in Jamaica in 2006 to that in 2008?
Offer a terse response. 0.78. What is the ratio of the Expenses (in $) in Macedonia in 2006 to that in 2008?
Make the answer very short. 1.19. What is the ratio of the Expenses (in $) in Portugal in 2006 to that in 2008?
Your answer should be very brief. 0.82. What is the ratio of the Expenses (in $) of Russian Federation in 2006 to that in 2008?
Provide a short and direct response. 1.11. What is the ratio of the Expenses (in $) in Jamaica in 2006 to that in 2009?
Your answer should be compact. 0.52. What is the ratio of the Expenses (in $) in Macedonia in 2006 to that in 2009?
Your answer should be compact. 1.28. What is the ratio of the Expenses (in $) of Portugal in 2006 to that in 2009?
Keep it short and to the point. 0.89. What is the ratio of the Expenses (in $) in Russian Federation in 2006 to that in 2009?
Offer a very short reply. 0.98. What is the ratio of the Expenses (in $) of Jamaica in 2006 to that in 2010?
Offer a terse response. 0.76. What is the ratio of the Expenses (in $) of Macedonia in 2006 to that in 2010?
Provide a succinct answer. 0.99. What is the ratio of the Expenses (in $) of Portugal in 2006 to that in 2010?
Provide a succinct answer. 0.86. What is the ratio of the Expenses (in $) in Russian Federation in 2006 to that in 2010?
Provide a short and direct response. 0.87. What is the ratio of the Expenses (in $) in Jamaica in 2006 to that in 2011?
Your answer should be compact. 0.81. What is the ratio of the Expenses (in $) of Macedonia in 2006 to that in 2011?
Offer a terse response. 0.9. What is the ratio of the Expenses (in $) in Portugal in 2006 to that in 2011?
Offer a very short reply. 0.61. What is the ratio of the Expenses (in $) in Russian Federation in 2006 to that in 2011?
Your response must be concise. 0.64. What is the ratio of the Expenses (in $) in Jamaica in 2006 to that in 2012?
Your response must be concise. 0.71. What is the ratio of the Expenses (in $) in Macedonia in 2006 to that in 2012?
Your response must be concise. 0.74. What is the ratio of the Expenses (in $) of Portugal in 2006 to that in 2012?
Give a very brief answer. 0.59. What is the ratio of the Expenses (in $) of Russian Federation in 2006 to that in 2012?
Your response must be concise. 0.52. What is the ratio of the Expenses (in $) in Jamaica in 2007 to that in 2008?
Keep it short and to the point. 0.83. What is the ratio of the Expenses (in $) of Macedonia in 2007 to that in 2008?
Give a very brief answer. 1.1. What is the ratio of the Expenses (in $) in Portugal in 2007 to that in 2008?
Ensure brevity in your answer.  0.9. What is the ratio of the Expenses (in $) in Russian Federation in 2007 to that in 2008?
Keep it short and to the point. 0.9. What is the ratio of the Expenses (in $) in Jamaica in 2007 to that in 2009?
Keep it short and to the point. 0.55. What is the ratio of the Expenses (in $) of Macedonia in 2007 to that in 2009?
Offer a terse response. 1.19. What is the ratio of the Expenses (in $) of Russian Federation in 2007 to that in 2009?
Offer a very short reply. 0.79. What is the ratio of the Expenses (in $) in Jamaica in 2007 to that in 2010?
Offer a terse response. 0.81. What is the ratio of the Expenses (in $) in Macedonia in 2007 to that in 2010?
Your answer should be compact. 0.92. What is the ratio of the Expenses (in $) of Portugal in 2007 to that in 2010?
Your answer should be compact. 0.95. What is the ratio of the Expenses (in $) of Russian Federation in 2007 to that in 2010?
Your response must be concise. 0.71. What is the ratio of the Expenses (in $) in Jamaica in 2007 to that in 2011?
Make the answer very short. 0.86. What is the ratio of the Expenses (in $) in Macedonia in 2007 to that in 2011?
Offer a terse response. 0.84. What is the ratio of the Expenses (in $) of Portugal in 2007 to that in 2011?
Provide a short and direct response. 0.68. What is the ratio of the Expenses (in $) of Russian Federation in 2007 to that in 2011?
Keep it short and to the point. 0.52. What is the ratio of the Expenses (in $) of Jamaica in 2007 to that in 2012?
Give a very brief answer. 0.76. What is the ratio of the Expenses (in $) in Macedonia in 2007 to that in 2012?
Offer a terse response. 0.69. What is the ratio of the Expenses (in $) in Portugal in 2007 to that in 2012?
Offer a terse response. 0.65. What is the ratio of the Expenses (in $) in Russian Federation in 2007 to that in 2012?
Make the answer very short. 0.42. What is the ratio of the Expenses (in $) of Jamaica in 2008 to that in 2009?
Keep it short and to the point. 0.67. What is the ratio of the Expenses (in $) of Macedonia in 2008 to that in 2009?
Provide a succinct answer. 1.08. What is the ratio of the Expenses (in $) of Portugal in 2008 to that in 2009?
Ensure brevity in your answer.  1.1. What is the ratio of the Expenses (in $) in Russian Federation in 2008 to that in 2009?
Provide a short and direct response. 0.88. What is the ratio of the Expenses (in $) of Jamaica in 2008 to that in 2010?
Your answer should be very brief. 0.98. What is the ratio of the Expenses (in $) in Macedonia in 2008 to that in 2010?
Provide a succinct answer. 0.83. What is the ratio of the Expenses (in $) of Portugal in 2008 to that in 2010?
Give a very brief answer. 1.05. What is the ratio of the Expenses (in $) in Russian Federation in 2008 to that in 2010?
Provide a short and direct response. 0.79. What is the ratio of the Expenses (in $) of Jamaica in 2008 to that in 2011?
Offer a terse response. 1.04. What is the ratio of the Expenses (in $) of Macedonia in 2008 to that in 2011?
Your answer should be very brief. 0.76. What is the ratio of the Expenses (in $) of Portugal in 2008 to that in 2011?
Your answer should be compact. 0.75. What is the ratio of the Expenses (in $) of Russian Federation in 2008 to that in 2011?
Your answer should be very brief. 0.57. What is the ratio of the Expenses (in $) of Jamaica in 2008 to that in 2012?
Your answer should be very brief. 0.92. What is the ratio of the Expenses (in $) of Macedonia in 2008 to that in 2012?
Keep it short and to the point. 0.63. What is the ratio of the Expenses (in $) of Portugal in 2008 to that in 2012?
Offer a terse response. 0.72. What is the ratio of the Expenses (in $) in Russian Federation in 2008 to that in 2012?
Give a very brief answer. 0.46. What is the ratio of the Expenses (in $) in Jamaica in 2009 to that in 2010?
Keep it short and to the point. 1.47. What is the ratio of the Expenses (in $) in Macedonia in 2009 to that in 2010?
Provide a succinct answer. 0.77. What is the ratio of the Expenses (in $) in Portugal in 2009 to that in 2010?
Give a very brief answer. 0.96. What is the ratio of the Expenses (in $) of Russian Federation in 2009 to that in 2010?
Your answer should be compact. 0.89. What is the ratio of the Expenses (in $) in Jamaica in 2009 to that in 2011?
Ensure brevity in your answer.  1.56. What is the ratio of the Expenses (in $) of Macedonia in 2009 to that in 2011?
Ensure brevity in your answer.  0.7. What is the ratio of the Expenses (in $) in Portugal in 2009 to that in 2011?
Your response must be concise. 0.68. What is the ratio of the Expenses (in $) in Russian Federation in 2009 to that in 2011?
Offer a very short reply. 0.65. What is the ratio of the Expenses (in $) in Jamaica in 2009 to that in 2012?
Ensure brevity in your answer.  1.38. What is the ratio of the Expenses (in $) of Macedonia in 2009 to that in 2012?
Provide a succinct answer. 0.58. What is the ratio of the Expenses (in $) of Portugal in 2009 to that in 2012?
Keep it short and to the point. 0.66. What is the ratio of the Expenses (in $) of Russian Federation in 2009 to that in 2012?
Your answer should be very brief. 0.53. What is the ratio of the Expenses (in $) of Jamaica in 2010 to that in 2011?
Offer a terse response. 1.06. What is the ratio of the Expenses (in $) in Macedonia in 2010 to that in 2011?
Your answer should be compact. 0.91. What is the ratio of the Expenses (in $) of Portugal in 2010 to that in 2011?
Provide a short and direct response. 0.71. What is the ratio of the Expenses (in $) in Russian Federation in 2010 to that in 2011?
Give a very brief answer. 0.73. What is the ratio of the Expenses (in $) in Jamaica in 2010 to that in 2012?
Give a very brief answer. 0.94. What is the ratio of the Expenses (in $) in Macedonia in 2010 to that in 2012?
Your answer should be compact. 0.75. What is the ratio of the Expenses (in $) in Portugal in 2010 to that in 2012?
Provide a short and direct response. 0.68. What is the ratio of the Expenses (in $) of Russian Federation in 2010 to that in 2012?
Provide a succinct answer. 0.59. What is the ratio of the Expenses (in $) of Jamaica in 2011 to that in 2012?
Provide a short and direct response. 0.88. What is the ratio of the Expenses (in $) in Macedonia in 2011 to that in 2012?
Offer a very short reply. 0.82. What is the ratio of the Expenses (in $) in Portugal in 2011 to that in 2012?
Make the answer very short. 0.96. What is the ratio of the Expenses (in $) of Russian Federation in 2011 to that in 2012?
Offer a terse response. 0.81. What is the difference between the highest and the second highest Expenses (in $) in Jamaica?
Ensure brevity in your answer.  5.21e+1. What is the difference between the highest and the second highest Expenses (in $) in Macedonia?
Your answer should be very brief. 7.45e+08. What is the difference between the highest and the second highest Expenses (in $) in Portugal?
Make the answer very short. 2.90e+08. What is the difference between the highest and the second highest Expenses (in $) in Russian Federation?
Offer a terse response. 6.30e+1. What is the difference between the highest and the lowest Expenses (in $) of Jamaica?
Offer a terse response. 1.04e+11. What is the difference between the highest and the lowest Expenses (in $) of Macedonia?
Offer a very short reply. 1.77e+09. What is the difference between the highest and the lowest Expenses (in $) in Portugal?
Offer a terse response. 3.35e+09. What is the difference between the highest and the lowest Expenses (in $) of Russian Federation?
Make the answer very short. 1.95e+11. 